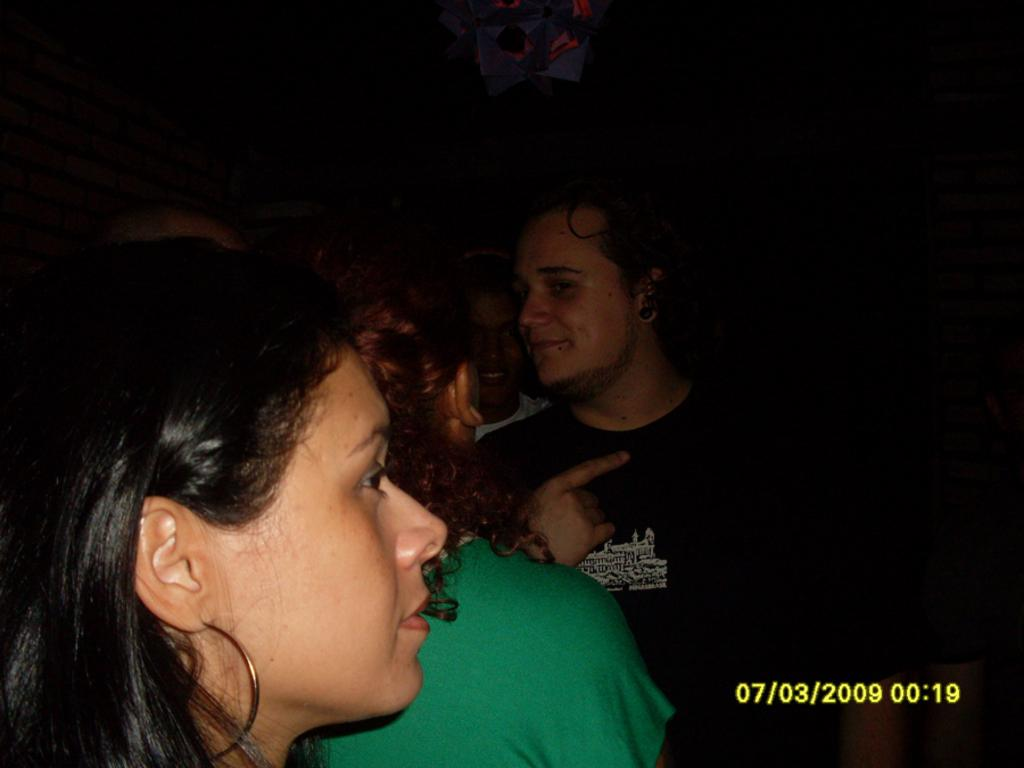What can be seen on the left side of the image? There are people on the left side of the image. What type of crib is visible in the image? There is no crib present in the image. What is the rate of the people walking in the image? The image does not depict people walking, nor does it provide any information about their speed or rate. --- 